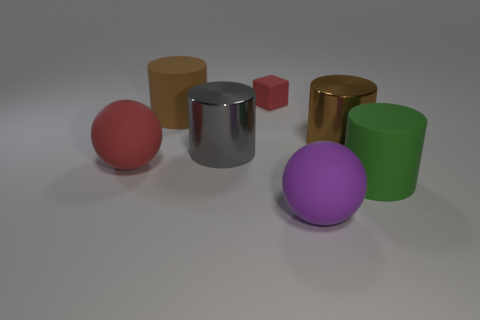Subtract 1 cylinders. How many cylinders are left? 3 Add 3 tiny rubber blocks. How many objects exist? 10 Subtract all spheres. How many objects are left? 5 Add 5 large gray objects. How many large gray objects exist? 6 Subtract 0 gray cubes. How many objects are left? 7 Subtract all purple spheres. Subtract all tiny red objects. How many objects are left? 5 Add 3 spheres. How many spheres are left? 5 